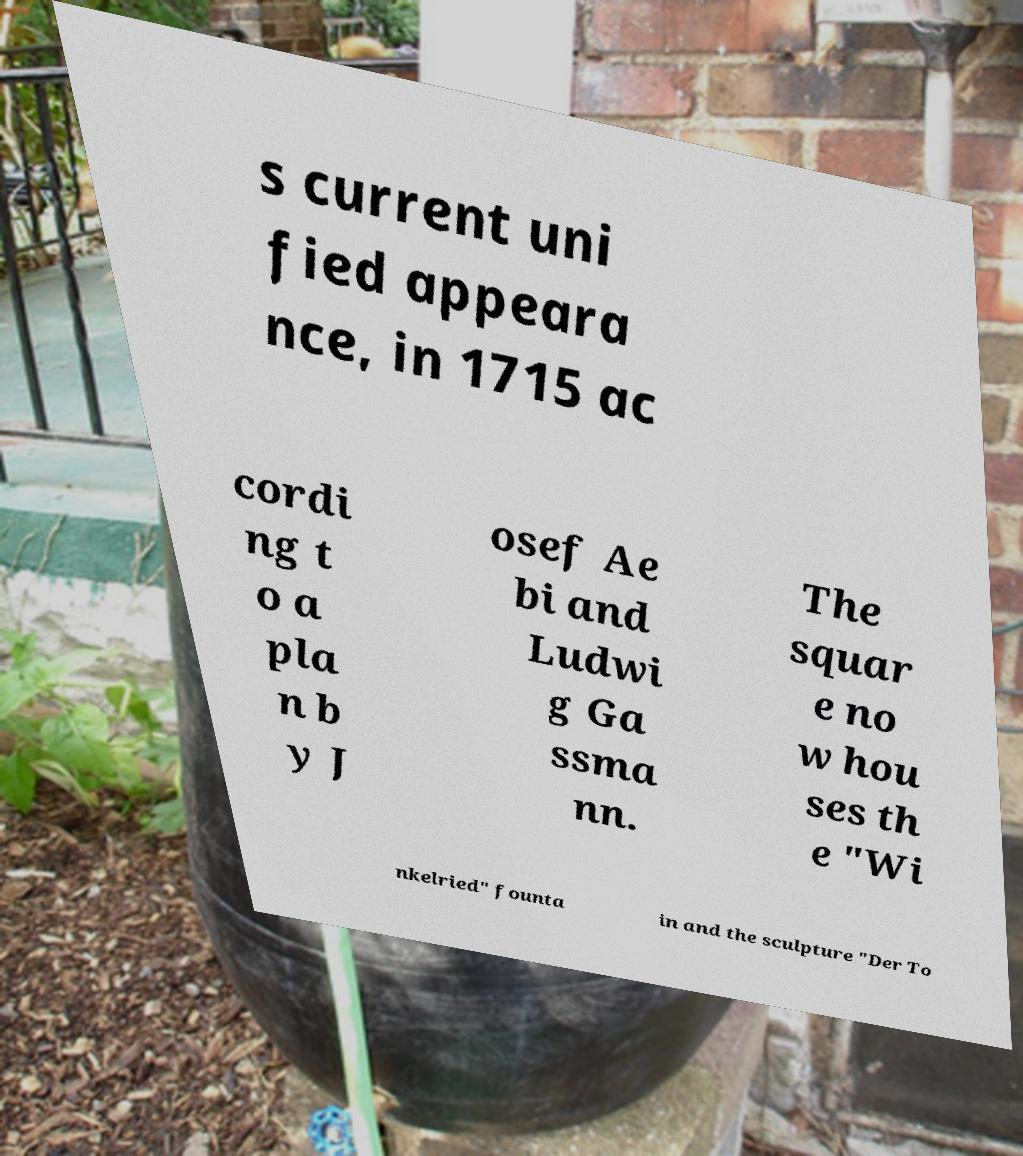Can you read and provide the text displayed in the image?This photo seems to have some interesting text. Can you extract and type it out for me? s current uni fied appeara nce, in 1715 ac cordi ng t o a pla n b y J osef Ae bi and Ludwi g Ga ssma nn. The squar e no w hou ses th e "Wi nkelried" founta in and the sculpture "Der To 